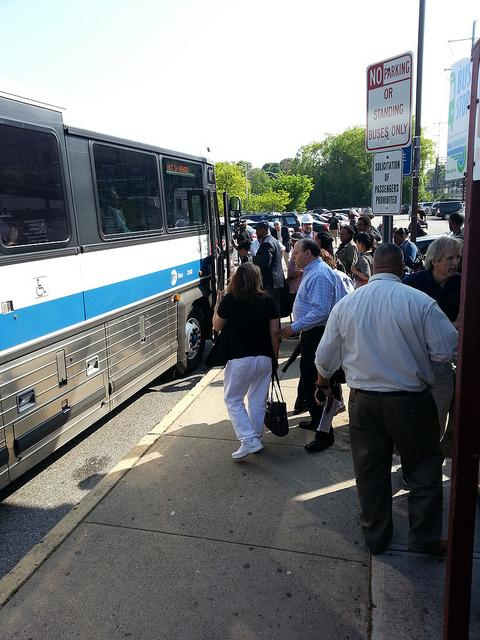What activity is prohibited here?

Choices:
A) eating
B) busses
C) taxis
D) boarding taxis 